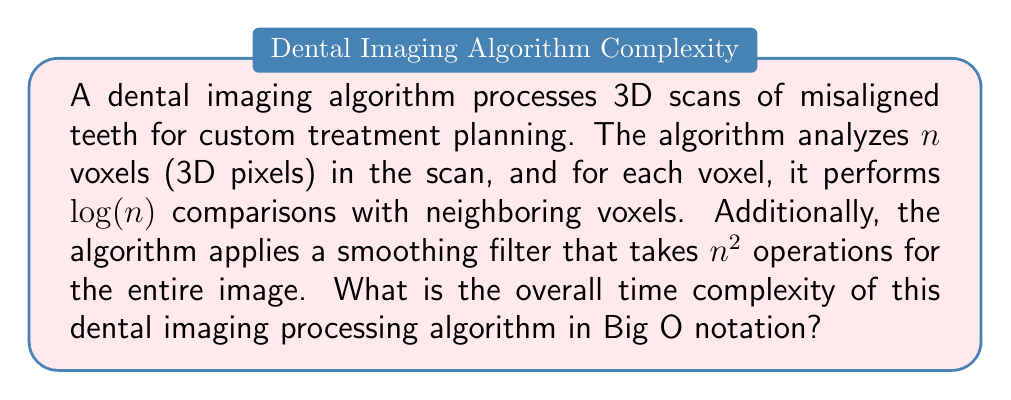What is the answer to this math problem? Let's break down the algorithm's operations and analyze their time complexities:

1. Voxel analysis:
   - The algorithm processes $n$ voxels.
   - For each voxel, it performs $\log(n)$ comparisons.
   - Total operations for voxel analysis: $n \cdot \log(n)$
   
2. Smoothing filter:
   - The filter takes $n^2$ operations for the entire image.

To determine the overall time complexity, we need to combine these operations:

$$T(n) = n \cdot \log(n) + n^2$$

Now, we need to identify the dominant term as $n$ grows larger:

- $n \cdot \log(n)$ grows slower than $n^2$
- $n^2$ is the dominant term

Therefore, the overall time complexity is determined by the smoothing filter operation.

In Big O notation, we express this as $O(n^2)$, which represents the upper bound of the algorithm's growth rate.
Answer: $O(n^2)$ 